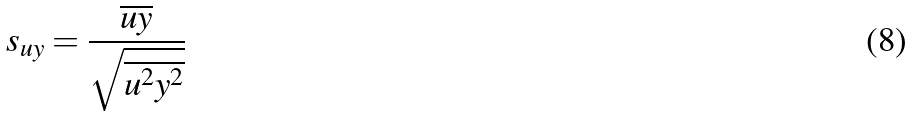Convert formula to latex. <formula><loc_0><loc_0><loc_500><loc_500>s _ { u y } = \frac { \overline { u y } } { \sqrt { \overline { u ^ { 2 } } \overline { y ^ { 2 } } } }</formula> 